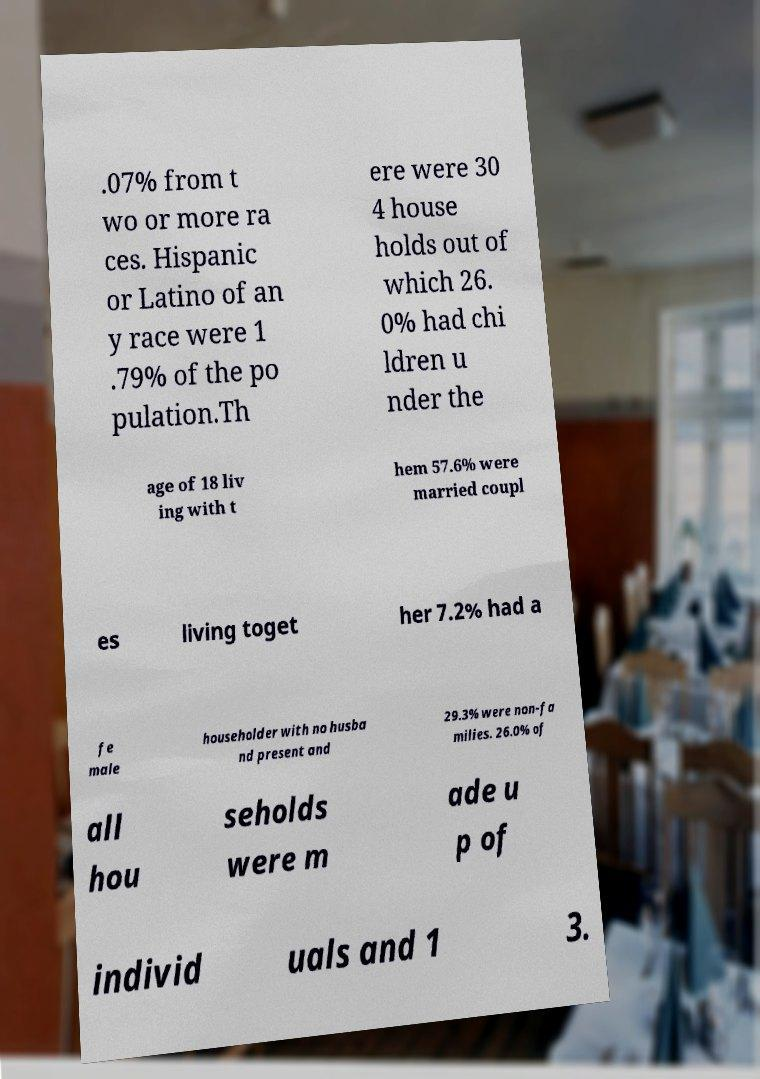Could you assist in decoding the text presented in this image and type it out clearly? .07% from t wo or more ra ces. Hispanic or Latino of an y race were 1 .79% of the po pulation.Th ere were 30 4 house holds out of which 26. 0% had chi ldren u nder the age of 18 liv ing with t hem 57.6% were married coupl es living toget her 7.2% had a fe male householder with no husba nd present and 29.3% were non-fa milies. 26.0% of all hou seholds were m ade u p of individ uals and 1 3. 